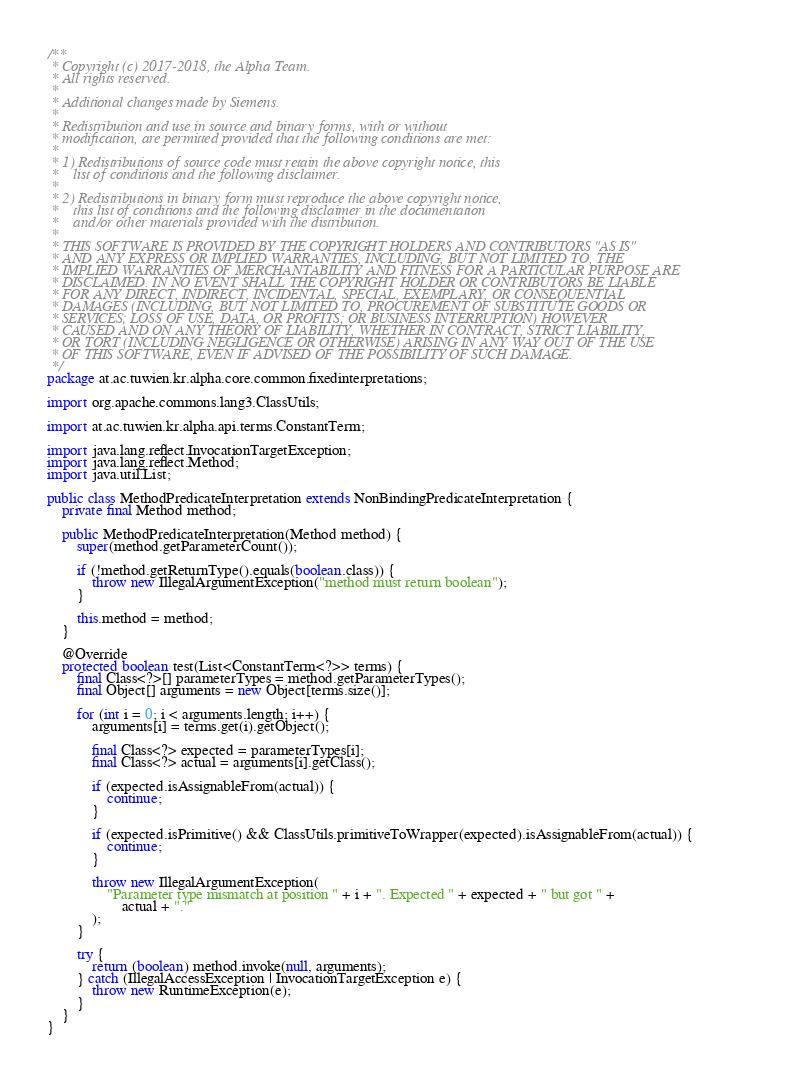<code> <loc_0><loc_0><loc_500><loc_500><_Java_>/**
 * Copyright (c) 2017-2018, the Alpha Team.
 * All rights reserved.
 * 
 * Additional changes made by Siemens.
 * 
 * Redistribution and use in source and binary forms, with or without
 * modification, are permitted provided that the following conditions are met:
 * 
 * 1) Redistributions of source code must retain the above copyright notice, this
 *    list of conditions and the following disclaimer.
 * 
 * 2) Redistributions in binary form must reproduce the above copyright notice,
 *    this list of conditions and the following disclaimer in the documentation
 *    and/or other materials provided with the distribution.
 * 
 * THIS SOFTWARE IS PROVIDED BY THE COPYRIGHT HOLDERS AND CONTRIBUTORS "AS IS"
 * AND ANY EXPRESS OR IMPLIED WARRANTIES, INCLUDING, BUT NOT LIMITED TO, THE
 * IMPLIED WARRANTIES OF MERCHANTABILITY AND FITNESS FOR A PARTICULAR PURPOSE ARE
 * DISCLAIMED. IN NO EVENT SHALL THE COPYRIGHT HOLDER OR CONTRIBUTORS BE LIABLE
 * FOR ANY DIRECT, INDIRECT, INCIDENTAL, SPECIAL, EXEMPLARY, OR CONSEQUENTIAL
 * DAMAGES (INCLUDING, BUT NOT LIMITED TO, PROCUREMENT OF SUBSTITUTE GOODS OR
 * SERVICES; LOSS OF USE, DATA, OR PROFITS; OR BUSINESS INTERRUPTION) HOWEVER
 * CAUSED AND ON ANY THEORY OF LIABILITY, WHETHER IN CONTRACT, STRICT LIABILITY,
 * OR TORT (INCLUDING NEGLIGENCE OR OTHERWISE) ARISING IN ANY WAY OUT OF THE USE
 * OF THIS SOFTWARE, EVEN IF ADVISED OF THE POSSIBILITY OF SUCH DAMAGE.
 */
package at.ac.tuwien.kr.alpha.core.common.fixedinterpretations;

import org.apache.commons.lang3.ClassUtils;

import at.ac.tuwien.kr.alpha.api.terms.ConstantTerm;

import java.lang.reflect.InvocationTargetException;
import java.lang.reflect.Method;
import java.util.List;

public class MethodPredicateInterpretation extends NonBindingPredicateInterpretation {
	private final Method method;

	public MethodPredicateInterpretation(Method method) {
		super(method.getParameterCount());

		if (!method.getReturnType().equals(boolean.class)) {
			throw new IllegalArgumentException("method must return boolean");
		}

		this.method = method;
	}

	@Override
	protected boolean test(List<ConstantTerm<?>> terms) {
		final Class<?>[] parameterTypes = method.getParameterTypes();
		final Object[] arguments = new Object[terms.size()];

		for (int i = 0; i < arguments.length; i++) {
			arguments[i] = terms.get(i).getObject();

			final Class<?> expected = parameterTypes[i];
			final Class<?> actual = arguments[i].getClass();

			if (expected.isAssignableFrom(actual)) {
				continue;
			}

			if (expected.isPrimitive() && ClassUtils.primitiveToWrapper(expected).isAssignableFrom(actual)) {
				continue;
			}

			throw new IllegalArgumentException(
				"Parameter type mismatch at position " + i + ". Expected " + expected + " but got " +
					actual + "."
			);
		}

		try {
			return (boolean) method.invoke(null, arguments);
		} catch (IllegalAccessException | InvocationTargetException e) {
			throw new RuntimeException(e);
		}
	}
}
</code> 